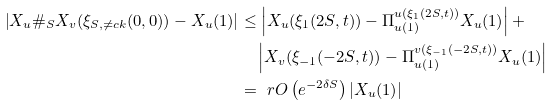<formula> <loc_0><loc_0><loc_500><loc_500>\left | X _ { u } \# _ { S } X _ { v } ( \xi _ { S , \ne c k } ( 0 , 0 ) ) - X _ { u } ( 1 ) \right | & \leq \left | X _ { u } ( \xi _ { 1 } ( 2 S , t ) ) - \Pi ^ { u ( \xi _ { 1 } ( 2 S , t ) ) } _ { u ( 1 ) } X _ { u } ( 1 ) \right | + \\ & \quad \left | X _ { v } ( \xi _ { - 1 } ( - 2 S , t ) ) - \Pi ^ { v ( \xi _ { - 1 } ( - 2 S , t ) ) } _ { u ( 1 ) } X _ { u } ( 1 ) \right | \\ & = \ r O \left ( e ^ { - 2 \delta S } \right ) \left | X _ { u } ( 1 ) \right |</formula> 